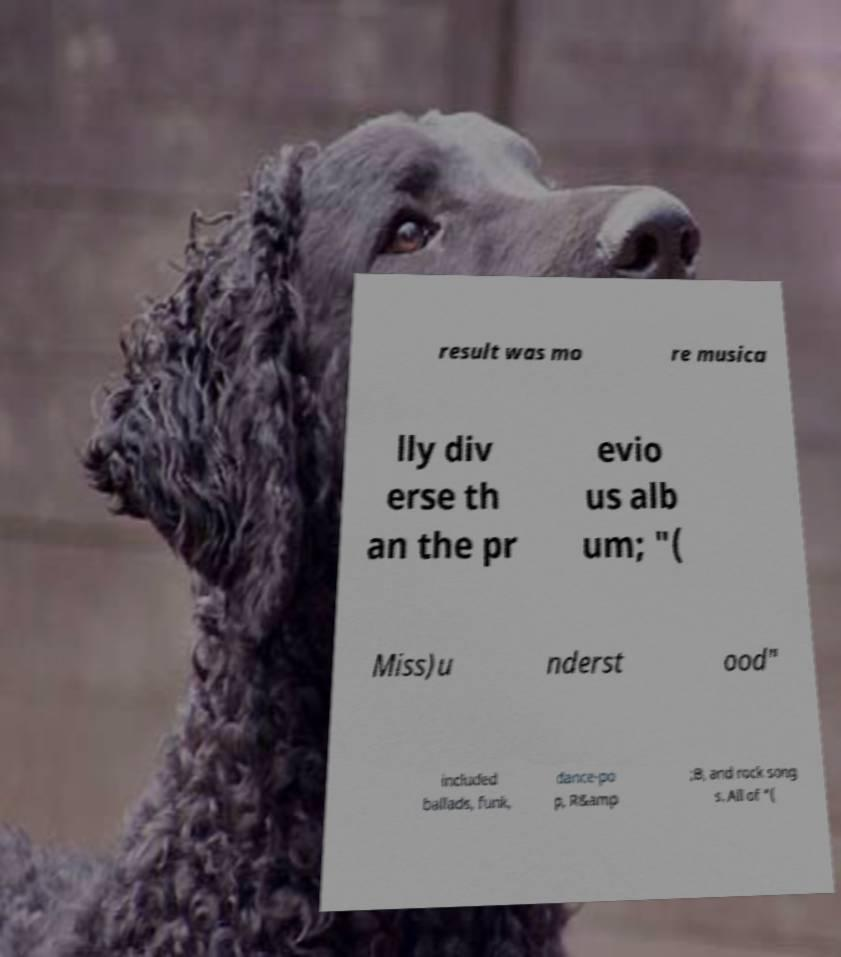Please identify and transcribe the text found in this image. result was mo re musica lly div erse th an the pr evio us alb um; "( Miss)u nderst ood" included ballads, funk, dance-po p, R&amp ;B, and rock song s. All of "( 